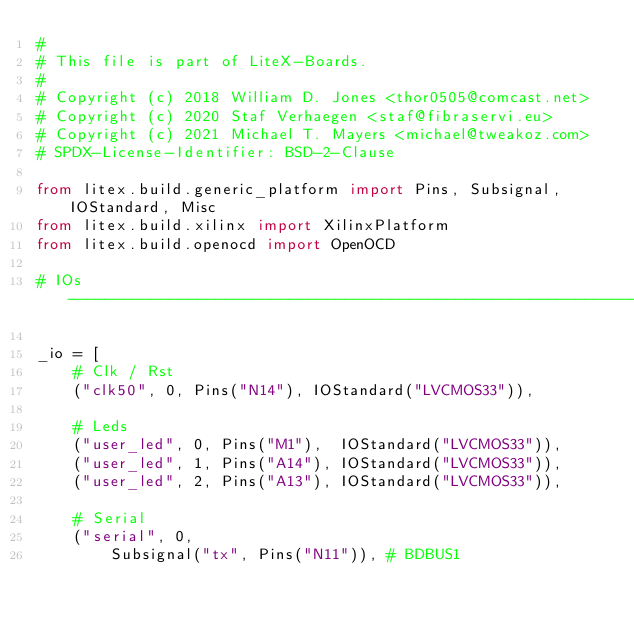Convert code to text. <code><loc_0><loc_0><loc_500><loc_500><_Python_>#
# This file is part of LiteX-Boards.
#
# Copyright (c) 2018 William D. Jones <thor0505@comcast.net>
# Copyright (c) 2020 Staf Verhaegen <staf@fibraservi.eu>
# Copyright (c) 2021 Michael T. Mayers <michael@tweakoz.com>
# SPDX-License-Identifier: BSD-2-Clause

from litex.build.generic_platform import Pins, Subsignal, IOStandard, Misc
from litex.build.xilinx import XilinxPlatform
from litex.build.openocd import OpenOCD

# IOs ----------------------------------------------------------------------------------------------

_io = [
    # Clk / Rst
    ("clk50", 0, Pins("N14"), IOStandard("LVCMOS33")),

    # Leds
    ("user_led", 0, Pins("M1"),  IOStandard("LVCMOS33")),
    ("user_led", 1, Pins("A14"), IOStandard("LVCMOS33")),
    ("user_led", 2, Pins("A13"), IOStandard("LVCMOS33")),

    # Serial
    ("serial", 0,
        Subsignal("tx", Pins("N11")), # BDBUS1</code> 